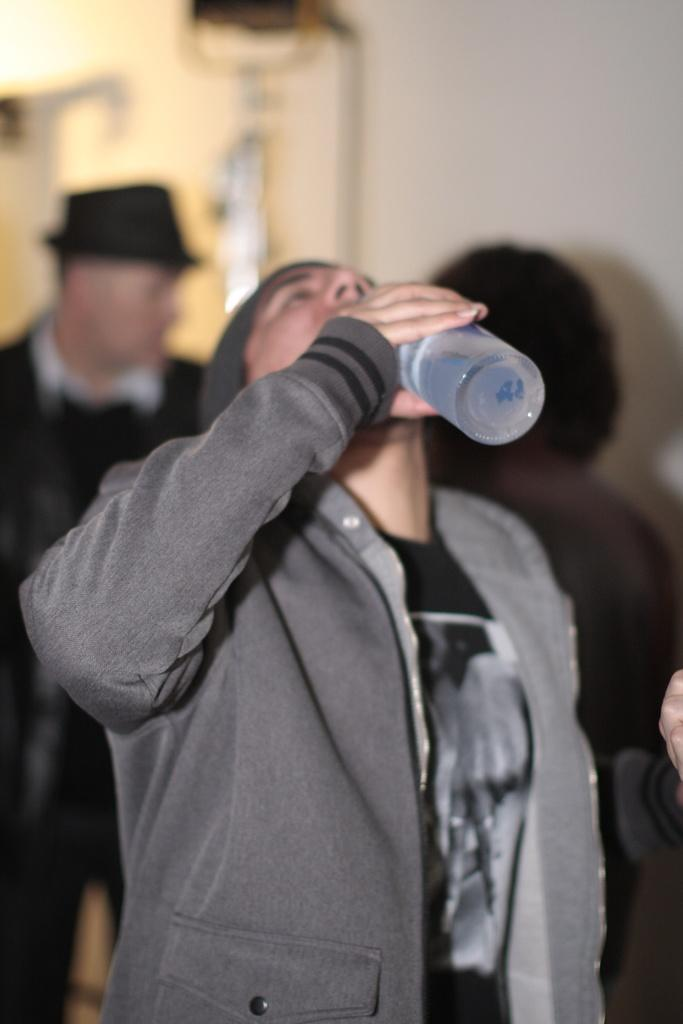Who is present in the image? There are people in the image. What is the man holding in the image? The man is holding a bottle. What is the man doing with the bottle? The man is drinking water. What type of amusement can be seen in the image? There is no amusement present in the image; it only shows a man holding a bottle and drinking water. What type of agreement is being made in the image? There is no agreement being made in the image; it only shows a man holding a bottle and drinking water. 